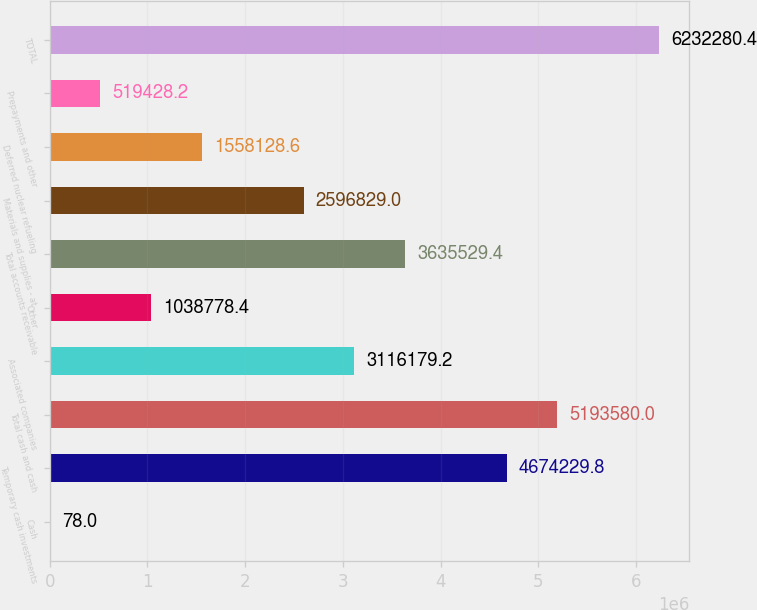Convert chart. <chart><loc_0><loc_0><loc_500><loc_500><bar_chart><fcel>Cash<fcel>Temporary cash investments<fcel>Total cash and cash<fcel>Associated companies<fcel>Other<fcel>Total accounts receivable<fcel>Materials and supplies - at<fcel>Deferred nuclear refueling<fcel>Prepayments and other<fcel>TOTAL<nl><fcel>78<fcel>4.67423e+06<fcel>5.19358e+06<fcel>3.11618e+06<fcel>1.03878e+06<fcel>3.63553e+06<fcel>2.59683e+06<fcel>1.55813e+06<fcel>519428<fcel>6.23228e+06<nl></chart> 